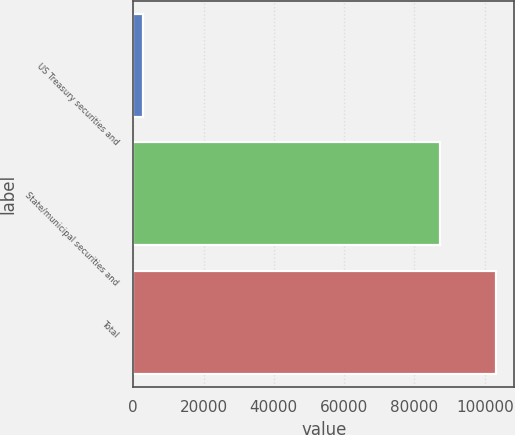<chart> <loc_0><loc_0><loc_500><loc_500><bar_chart><fcel>US Treasury securities and<fcel>State/municipal securities and<fcel>Total<nl><fcel>2797<fcel>87198<fcel>103273<nl></chart> 